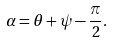Convert formula to latex. <formula><loc_0><loc_0><loc_500><loc_500>\alpha = \theta + \psi - { \frac { \pi } { 2 } } .</formula> 